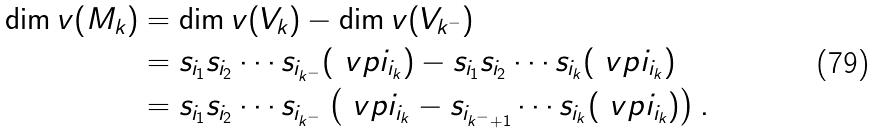Convert formula to latex. <formula><loc_0><loc_0><loc_500><loc_500>\dim v ( M _ { k } ) & = \dim v ( V _ { k } ) - \dim v ( V _ { k ^ { - } } ) \\ & = s _ { i _ { 1 } } s _ { i _ { 2 } } \cdots s _ { i _ { k ^ { - } } } ( \ v p i _ { i _ { k } } ) - s _ { i _ { 1 } } s _ { i _ { 2 } } \cdots s _ { i _ { k } } ( \ v p i _ { i _ { k } } ) \\ & = s _ { i _ { 1 } } s _ { i _ { 2 } } \cdots s _ { i _ { k ^ { - } } } \left ( \ v p i _ { i _ { k } } - s _ { i _ { k ^ { - } + 1 } } \cdots s _ { i _ { k } } ( \ v p i _ { i _ { k } } ) \right ) .</formula> 